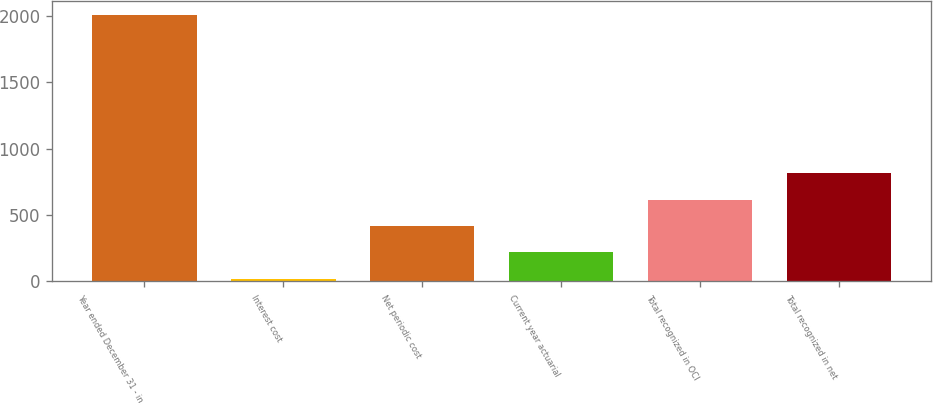Convert chart to OTSL. <chart><loc_0><loc_0><loc_500><loc_500><bar_chart><fcel>Year ended December 31 - in<fcel>Interest cost<fcel>Net periodic cost<fcel>Current year actuarial<fcel>Total recognized in OCI<fcel>Total recognized in net<nl><fcel>2010<fcel>20<fcel>418<fcel>219<fcel>617<fcel>816<nl></chart> 